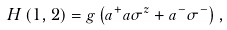Convert formula to latex. <formula><loc_0><loc_0><loc_500><loc_500>H \left ( 1 , 2 \right ) = g \left ( a ^ { + } a \sigma ^ { z } + a ^ { - } \sigma ^ { - } \right ) ,</formula> 